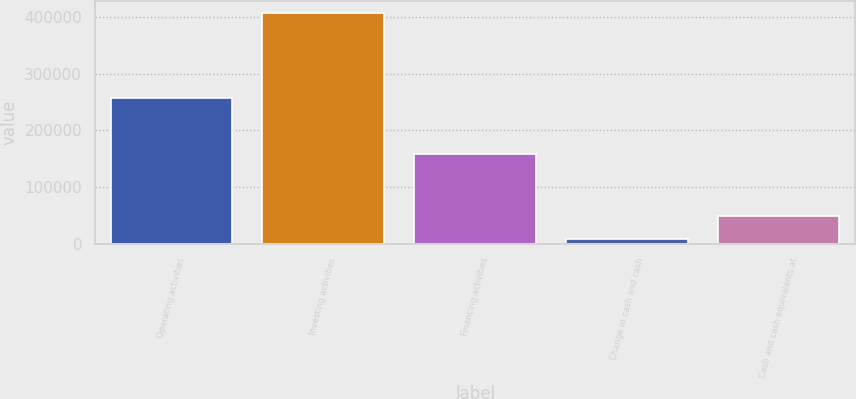Convert chart to OTSL. <chart><loc_0><loc_0><loc_500><loc_500><bar_chart><fcel>Operating activities<fcel>Investing activities<fcel>Financing activities<fcel>Change in cash and cash<fcel>Cash and cash equivalents at<nl><fcel>257572<fcel>407260<fcel>158175<fcel>8487<fcel>48364.3<nl></chart> 